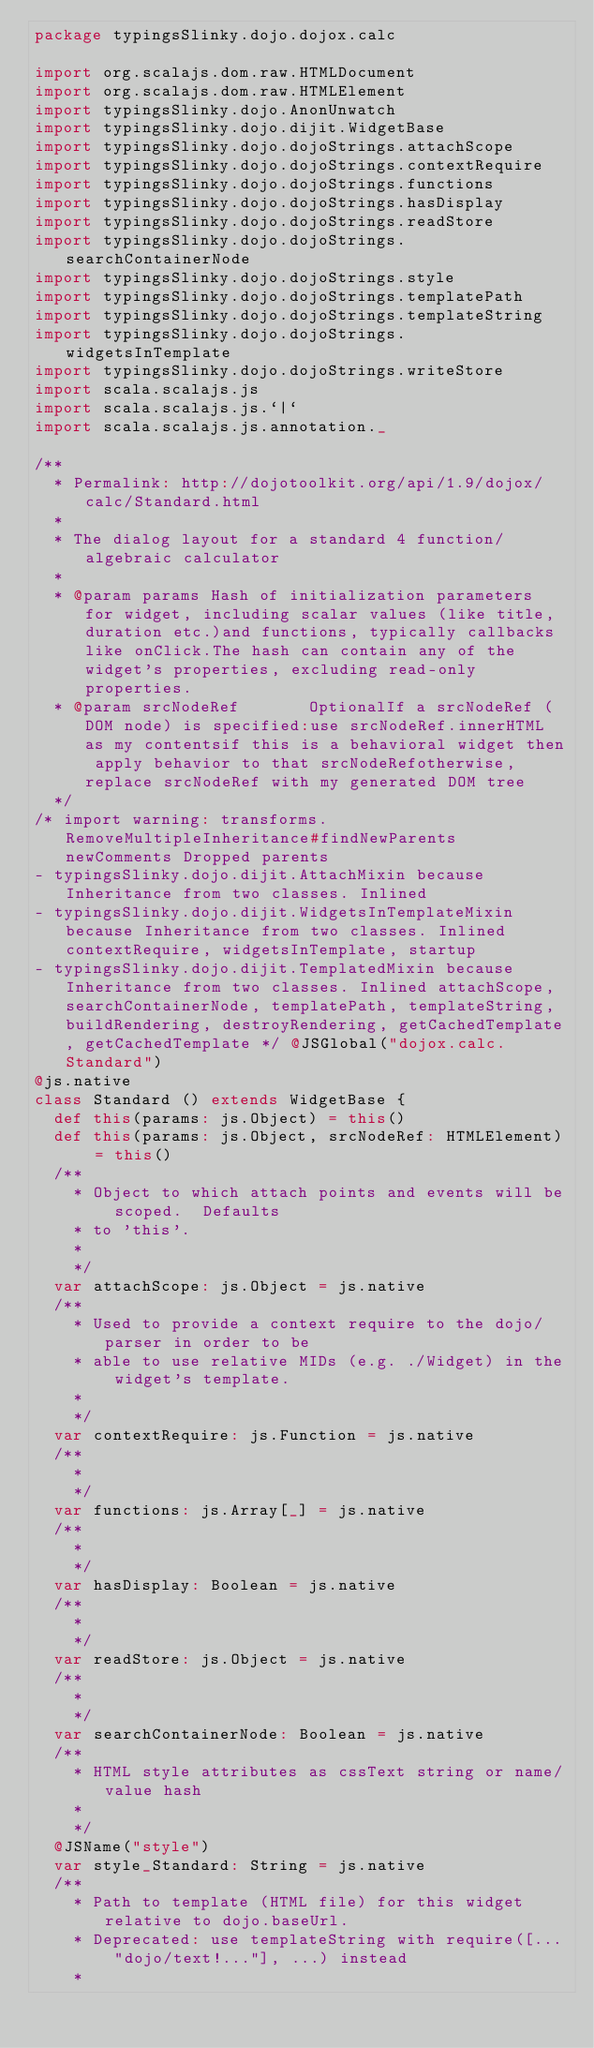Convert code to text. <code><loc_0><loc_0><loc_500><loc_500><_Scala_>package typingsSlinky.dojo.dojox.calc

import org.scalajs.dom.raw.HTMLDocument
import org.scalajs.dom.raw.HTMLElement
import typingsSlinky.dojo.AnonUnwatch
import typingsSlinky.dojo.dijit.WidgetBase
import typingsSlinky.dojo.dojoStrings.attachScope
import typingsSlinky.dojo.dojoStrings.contextRequire
import typingsSlinky.dojo.dojoStrings.functions
import typingsSlinky.dojo.dojoStrings.hasDisplay
import typingsSlinky.dojo.dojoStrings.readStore
import typingsSlinky.dojo.dojoStrings.searchContainerNode
import typingsSlinky.dojo.dojoStrings.style
import typingsSlinky.dojo.dojoStrings.templatePath
import typingsSlinky.dojo.dojoStrings.templateString
import typingsSlinky.dojo.dojoStrings.widgetsInTemplate
import typingsSlinky.dojo.dojoStrings.writeStore
import scala.scalajs.js
import scala.scalajs.js.`|`
import scala.scalajs.js.annotation._

/**
  * Permalink: http://dojotoolkit.org/api/1.9/dojox/calc/Standard.html
  *
  * The dialog layout for a standard 4 function/algebraic calculator
  *
  * @param params Hash of initialization parameters for widget, including scalar values (like title, duration etc.)and functions, typically callbacks like onClick.The hash can contain any of the widget's properties, excluding read-only properties.
  * @param srcNodeRef       OptionalIf a srcNodeRef (DOM node) is specified:use srcNodeRef.innerHTML as my contentsif this is a behavioral widget then apply behavior to that srcNodeRefotherwise, replace srcNodeRef with my generated DOM tree
  */
/* import warning: transforms.RemoveMultipleInheritance#findNewParents newComments Dropped parents 
- typingsSlinky.dojo.dijit.AttachMixin because Inheritance from two classes. Inlined 
- typingsSlinky.dojo.dijit.WidgetsInTemplateMixin because Inheritance from two classes. Inlined contextRequire, widgetsInTemplate, startup
- typingsSlinky.dojo.dijit.TemplatedMixin because Inheritance from two classes. Inlined attachScope, searchContainerNode, templatePath, templateString, buildRendering, destroyRendering, getCachedTemplate, getCachedTemplate */ @JSGlobal("dojox.calc.Standard")
@js.native
class Standard () extends WidgetBase {
  def this(params: js.Object) = this()
  def this(params: js.Object, srcNodeRef: HTMLElement) = this()
  /**
    * Object to which attach points and events will be scoped.  Defaults
    * to 'this'.
    *
    */
  var attachScope: js.Object = js.native
  /**
    * Used to provide a context require to the dojo/parser in order to be
    * able to use relative MIDs (e.g. ./Widget) in the widget's template.
    *
    */
  var contextRequire: js.Function = js.native
  /**
    *
    */
  var functions: js.Array[_] = js.native
  /**
    *
    */
  var hasDisplay: Boolean = js.native
  /**
    *
    */
  var readStore: js.Object = js.native
  /**
    *
    */
  var searchContainerNode: Boolean = js.native
  /**
    * HTML style attributes as cssText string or name/value hash
    *
    */
  @JSName("style")
  var style_Standard: String = js.native
  /**
    * Path to template (HTML file) for this widget relative to dojo.baseUrl.
    * Deprecated: use templateString with require([... "dojo/text!..."], ...) instead
    *</code> 